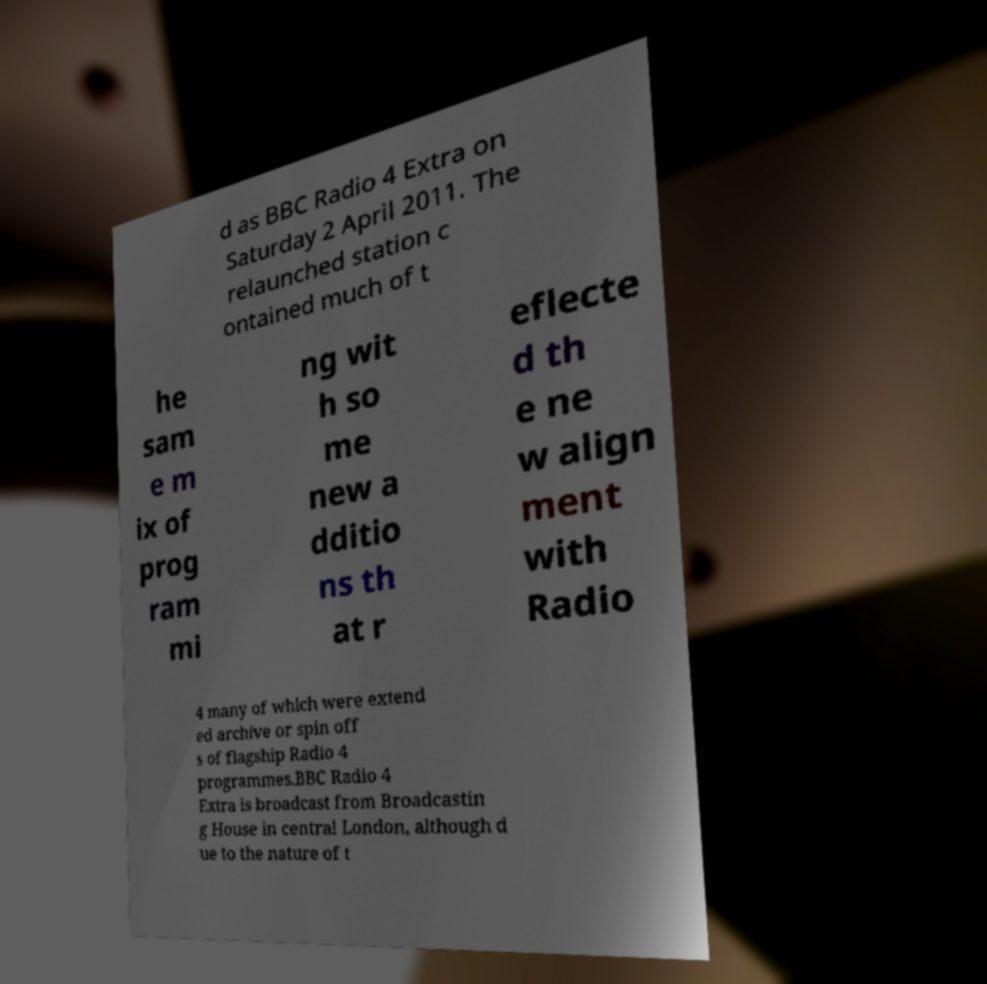Could you extract and type out the text from this image? d as BBC Radio 4 Extra on Saturday 2 April 2011. The relaunched station c ontained much of t he sam e m ix of prog ram mi ng wit h so me new a dditio ns th at r eflecte d th e ne w align ment with Radio 4 many of which were extend ed archive or spin off s of flagship Radio 4 programmes.BBC Radio 4 Extra is broadcast from Broadcastin g House in central London, although d ue to the nature of t 